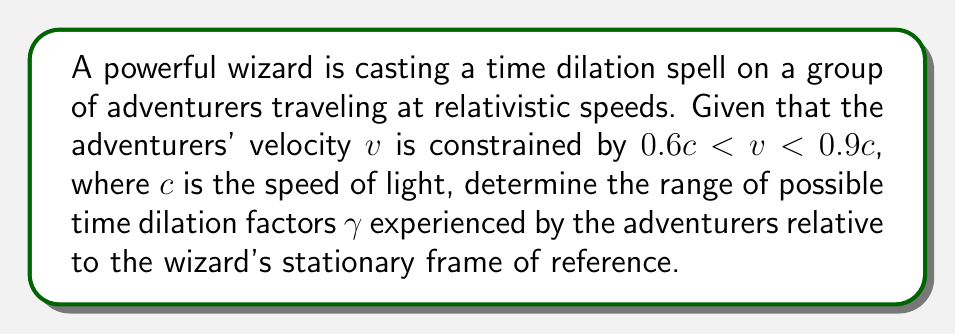Could you help me with this problem? To solve this problem, we'll follow these steps:

1) The time dilation factor $\gamma$ is given by the Lorentz factor:

   $$\gamma = \frac{1}{\sqrt{1 - \frac{v^2}{c^2}}}$$

2) We need to find the minimum and maximum values of $\gamma$ given the velocity constraints.

3) For the minimum $\gamma$, we use the lower bound of velocity: $v = 0.6c$

   $$\gamma_{\text{min}} = \frac{1}{\sqrt{1 - \frac{(0.6c)^2}{c^2}}} = \frac{1}{\sqrt{1 - 0.36}} = \frac{1}{\sqrt{0.64}} = \frac{1}{0.8} = 1.25$$

4) For the maximum $\gamma$, we use the upper bound of velocity: $v = 0.9c$

   $$\gamma_{\text{max}} = \frac{1}{\sqrt{1 - \frac{(0.9c)^2}{c^2}}} = \frac{1}{\sqrt{1 - 0.81}} = \frac{1}{\sqrt{0.19}} \approx 2.29$$

5) Therefore, the range of possible time dilation factors is:

   $$1.25 \leq \gamma \leq 2.29$$

This means that for every 1 second that passes in the wizard's frame, between 1.25 and 2.29 seconds will pass for the adventurers.
Answer: $1.25 \leq \gamma \leq 2.29$ 